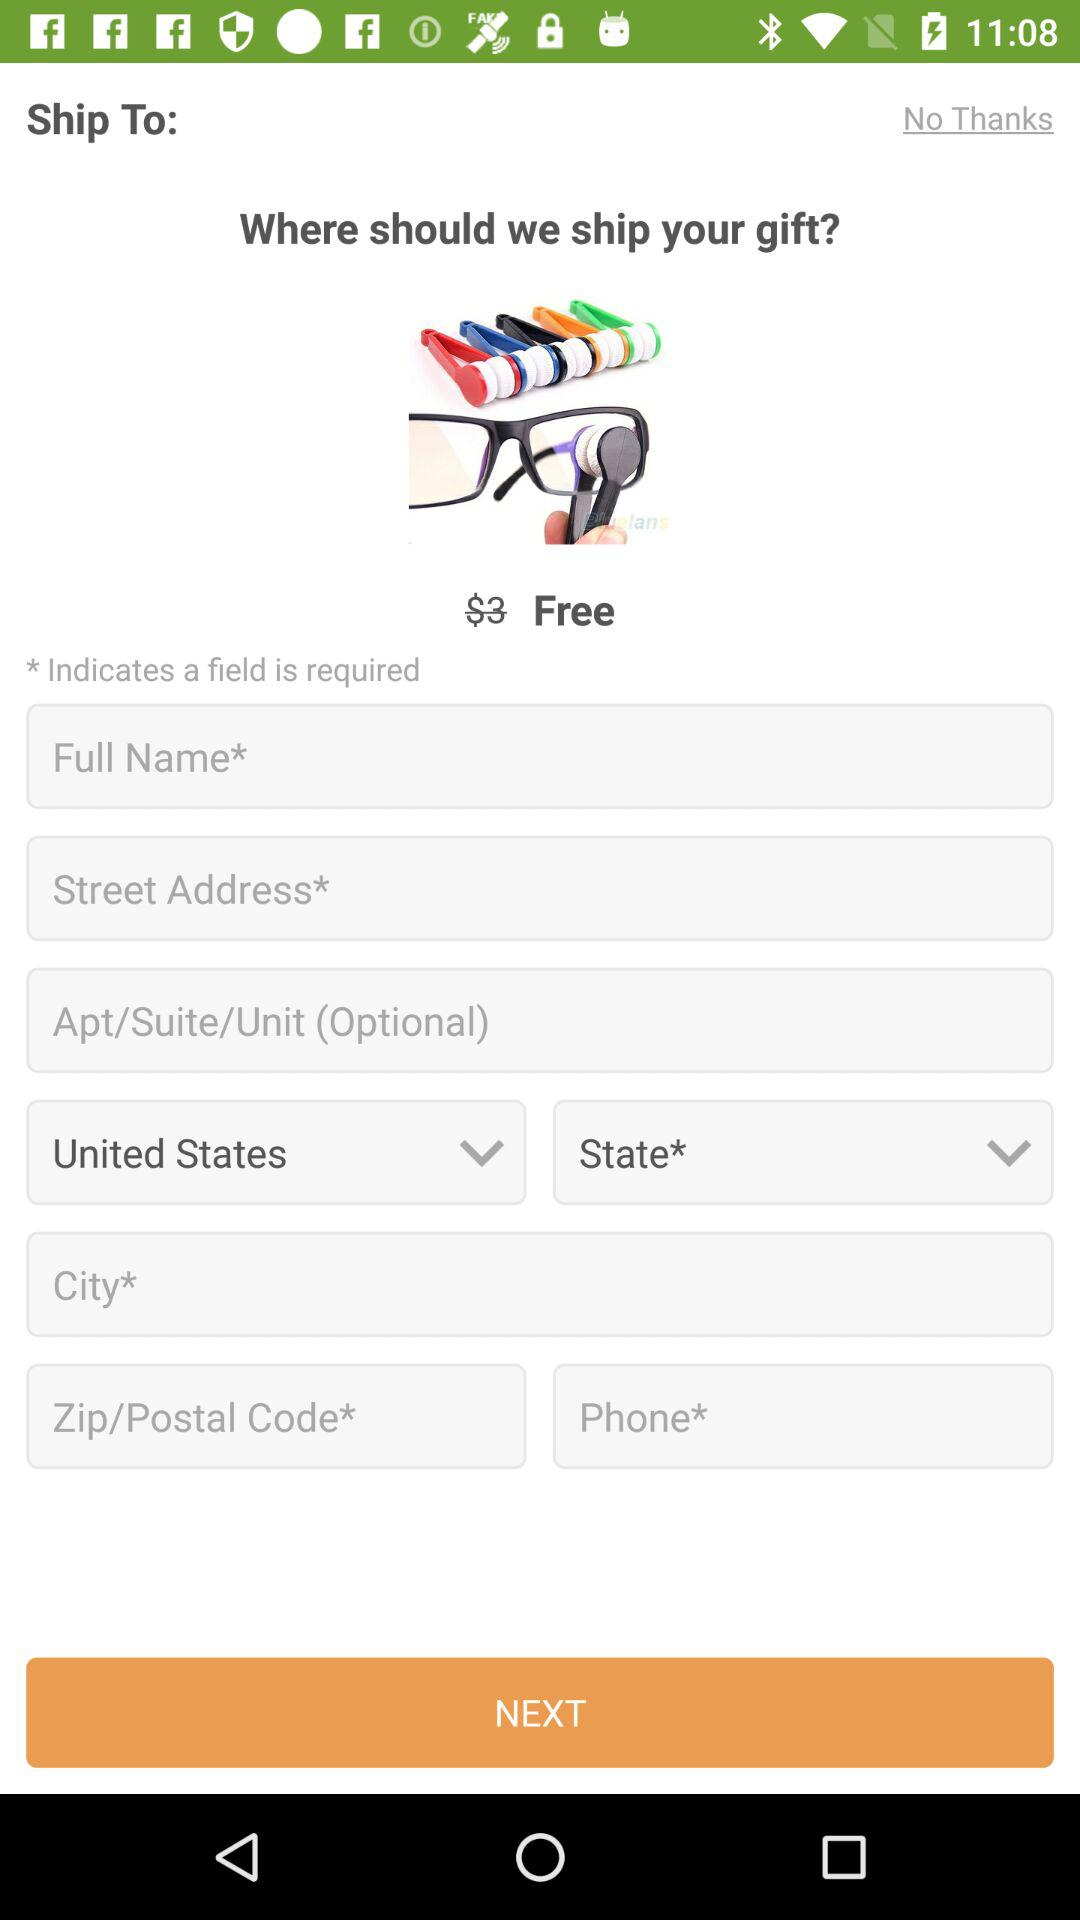How many text inputs are required?
Answer the question using a single word or phrase. 5 